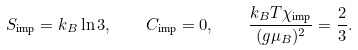<formula> <loc_0><loc_0><loc_500><loc_500>S _ { \text {imp} } = k _ { B } \ln 3 , \quad C _ { \text {imp} } = 0 , \quad \frac { k _ { B } T \chi _ { \text {imp} } } { ( g \mu _ { B } ) ^ { 2 } } = \frac { 2 } { 3 } .</formula> 